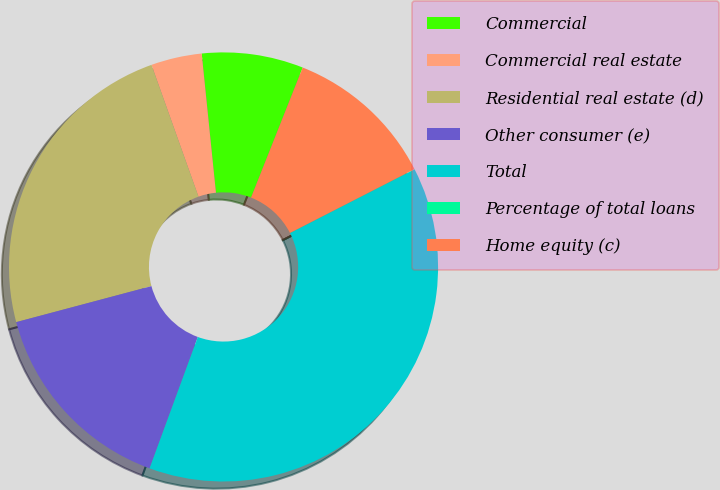Convert chart. <chart><loc_0><loc_0><loc_500><loc_500><pie_chart><fcel>Commercial<fcel>Commercial real estate<fcel>Residential real estate (d)<fcel>Other consumer (e)<fcel>Total<fcel>Percentage of total loans<fcel>Home equity (c)<nl><fcel>7.64%<fcel>3.83%<fcel>23.69%<fcel>15.26%<fcel>38.12%<fcel>0.02%<fcel>11.45%<nl></chart> 